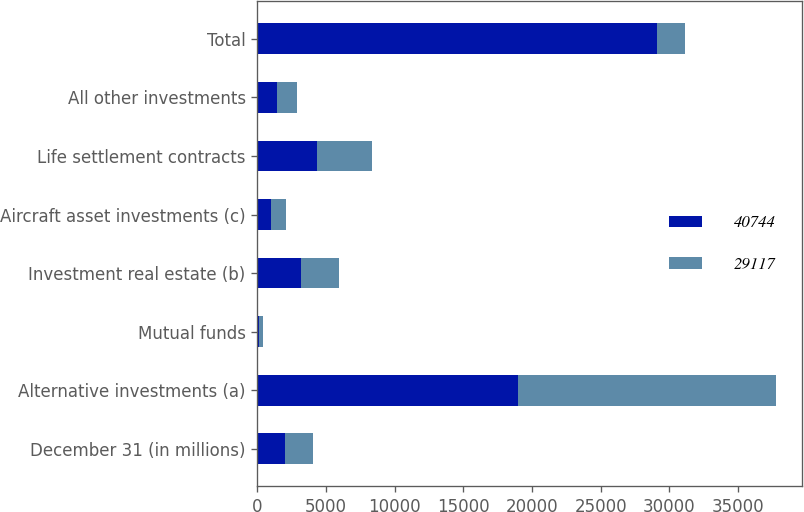Convert chart to OTSL. <chart><loc_0><loc_0><loc_500><loc_500><stacked_bar_chart><ecel><fcel>December 31 (in millions)<fcel>Alternative investments (a)<fcel>Mutual funds<fcel>Investment real estate (b)<fcel>Aircraft asset investments (c)<fcel>Life settlement contracts<fcel>All other investments<fcel>Total<nl><fcel>40744<fcel>2012<fcel>18990<fcel>128<fcel>3195<fcel>984<fcel>4357<fcel>1463<fcel>29117<nl><fcel>29117<fcel>2011<fcel>18793<fcel>258<fcel>2778<fcel>1100<fcel>4006<fcel>1442<fcel>2012<nl></chart> 